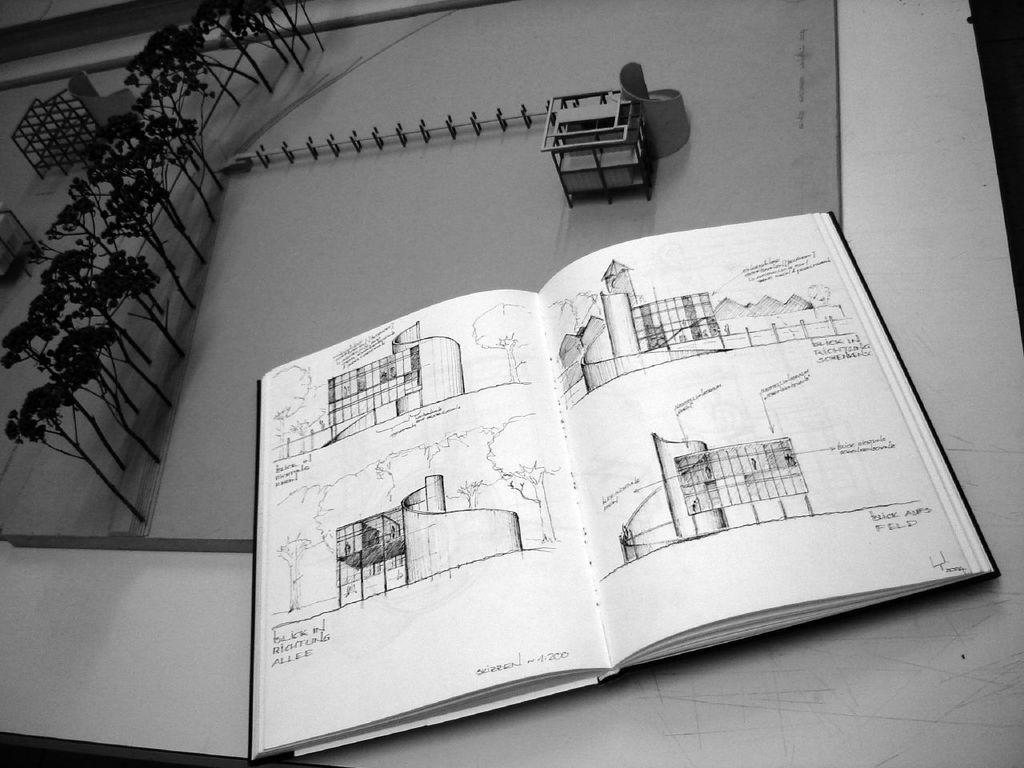Could you give a brief overview of what you see in this image? In this image we can see drawings on a piece of paper, on top of the paper we can see an open book with drawings in it as well. 